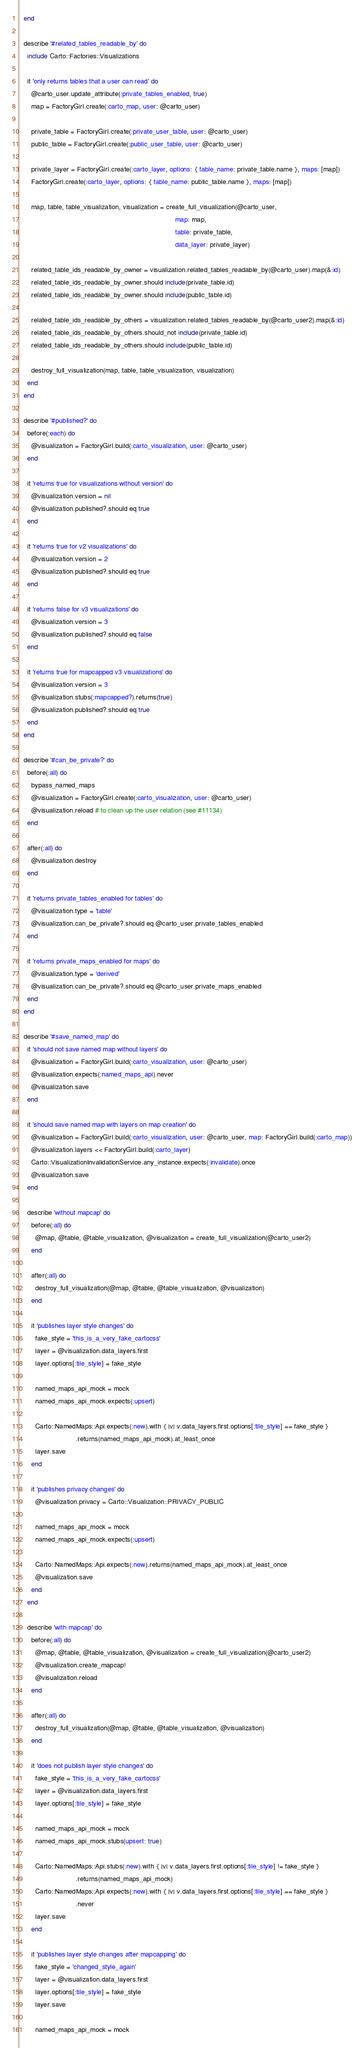<code> <loc_0><loc_0><loc_500><loc_500><_Ruby_>  end

  describe '#related_tables_readable_by' do
    include Carto::Factories::Visualizations

    it 'only returns tables that a user can read' do
      @carto_user.update_attribute(:private_tables_enabled, true)
      map = FactoryGirl.create(:carto_map, user: @carto_user)

      private_table = FactoryGirl.create(:private_user_table, user: @carto_user)
      public_table = FactoryGirl.create(:public_user_table, user: @carto_user)

      private_layer = FactoryGirl.create(:carto_layer, options: { table_name: private_table.name }, maps: [map])
      FactoryGirl.create(:carto_layer, options: { table_name: public_table.name }, maps: [map])

      map, table, table_visualization, visualization = create_full_visualization(@carto_user,
                                                                                 map: map,
                                                                                 table: private_table,
                                                                                 data_layer: private_layer)

      related_table_ids_readable_by_owner = visualization.related_tables_readable_by(@carto_user).map(&:id)
      related_table_ids_readable_by_owner.should include(private_table.id)
      related_table_ids_readable_by_owner.should include(public_table.id)

      related_table_ids_readable_by_others = visualization.related_tables_readable_by(@carto_user2).map(&:id)
      related_table_ids_readable_by_others.should_not include(private_table.id)
      related_table_ids_readable_by_others.should include(public_table.id)

      destroy_full_visualization(map, table, table_visualization, visualization)
    end
  end

  describe '#published?' do
    before(:each) do
      @visualization = FactoryGirl.build(:carto_visualization, user: @carto_user)
    end

    it 'returns true for visualizations without version' do
      @visualization.version = nil
      @visualization.published?.should eq true
    end

    it 'returns true for v2 visualizations' do
      @visualization.version = 2
      @visualization.published?.should eq true
    end

    it 'returns false for v3 visualizations' do
      @visualization.version = 3
      @visualization.published?.should eq false
    end

    it 'returns true for mapcapped v3 visualizations' do
      @visualization.version = 3
      @visualization.stubs(:mapcapped?).returns(true)
      @visualization.published?.should eq true
    end
  end

  describe '#can_be_private?' do
    before(:all) do
      bypass_named_maps
      @visualization = FactoryGirl.create(:carto_visualization, user: @carto_user)
      @visualization.reload # to clean up the user relation (see #11134)
    end

    after(:all) do
      @visualization.destroy
    end

    it 'returns private_tables_enabled for tables' do
      @visualization.type = 'table'
      @visualization.can_be_private?.should eq @carto_user.private_tables_enabled
    end

    it 'returns private_maps_enabled for maps' do
      @visualization.type = 'derived'
      @visualization.can_be_private?.should eq @carto_user.private_maps_enabled
    end
  end

  describe '#save_named_map' do
    it 'should not save named map without layers' do
      @visualization = FactoryGirl.build(:carto_visualization, user: @carto_user)
      @visualization.expects(:named_maps_api).never
      @visualization.save
    end

    it 'should save named map with layers on map creation' do
      @visualization = FactoryGirl.build(:carto_visualization, user: @carto_user, map: FactoryGirl.build(:carto_map))
      @visualization.layers << FactoryGirl.build(:carto_layer)
      Carto::VisualizationInvalidationService.any_instance.expects(:invalidate).once
      @visualization.save
    end

    describe 'without mapcap' do
      before(:all) do
        @map, @table, @table_visualization, @visualization = create_full_visualization(@carto_user2)
      end

      after(:all) do
        destroy_full_visualization(@map, @table, @table_visualization, @visualization)
      end

      it 'publishes layer style changes' do
        fake_style = 'this_is_a_very_fake_cartocss'
        layer = @visualization.data_layers.first
        layer.options[:tile_style] = fake_style

        named_maps_api_mock = mock
        named_maps_api_mock.expects(:upsert)

        Carto::NamedMaps::Api.expects(:new).with { |v| v.data_layers.first.options[:tile_style] == fake_style }
                             .returns(named_maps_api_mock).at_least_once
        layer.save
      end

      it 'publishes privacy changes' do
        @visualization.privacy = Carto::Visualization::PRIVACY_PUBLIC

        named_maps_api_mock = mock
        named_maps_api_mock.expects(:upsert)

        Carto::NamedMaps::Api.expects(:new).returns(named_maps_api_mock).at_least_once
        @visualization.save
      end
    end

    describe 'with mapcap' do
      before(:all) do
        @map, @table, @table_visualization, @visualization = create_full_visualization(@carto_user2)
        @visualization.create_mapcap!
        @visualization.reload
      end

      after(:all) do
        destroy_full_visualization(@map, @table, @table_visualization, @visualization)
      end

      it 'does not publish layer style changes' do
        fake_style = 'this_is_a_very_fake_cartocss'
        layer = @visualization.data_layers.first
        layer.options[:tile_style] = fake_style

        named_maps_api_mock = mock
        named_maps_api_mock.stubs(upsert: true)

        Carto::NamedMaps::Api.stubs(:new).with { |v| v.data_layers.first.options[:tile_style] != fake_style }
                             .returns(named_maps_api_mock)
        Carto::NamedMaps::Api.expects(:new).with { |v| v.data_layers.first.options[:tile_style] == fake_style }
                             .never
        layer.save
      end

      it 'publishes layer style changes after mapcapping' do
        fake_style = 'changed_style_again'
        layer = @visualization.data_layers.first
        layer.options[:tile_style] = fake_style
        layer.save

        named_maps_api_mock = mock</code> 